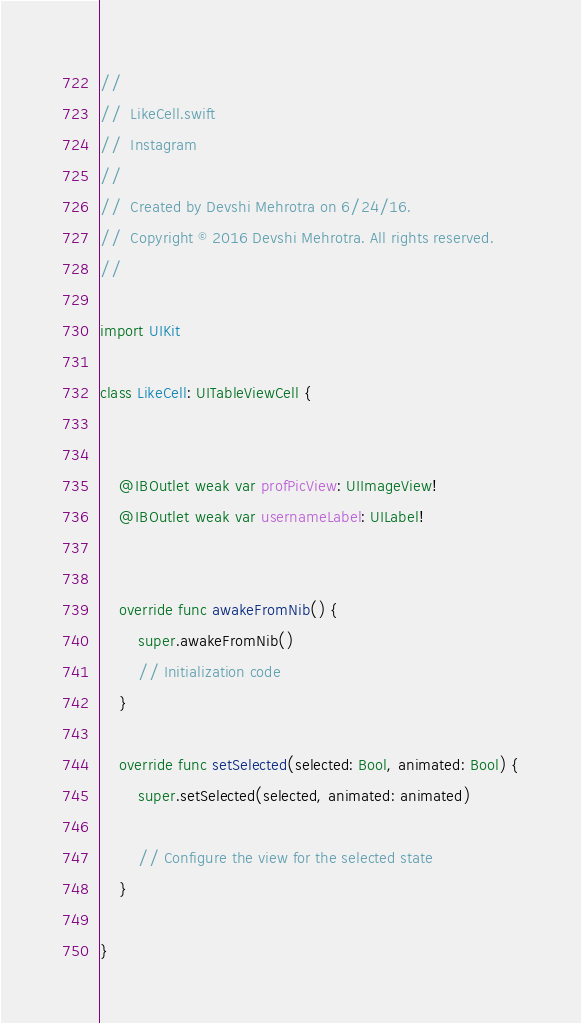Convert code to text. <code><loc_0><loc_0><loc_500><loc_500><_Swift_>//
//  LikeCell.swift
//  Instagram
//
//  Created by Devshi Mehrotra on 6/24/16.
//  Copyright © 2016 Devshi Mehrotra. All rights reserved.
//

import UIKit

class LikeCell: UITableViewCell {

    
    @IBOutlet weak var profPicView: UIImageView!
    @IBOutlet weak var usernameLabel: UILabel!
    
    
    override func awakeFromNib() {
        super.awakeFromNib()
        // Initialization code
    }

    override func setSelected(selected: Bool, animated: Bool) {
        super.setSelected(selected, animated: animated)

        // Configure the view for the selected state
    }

}
</code> 